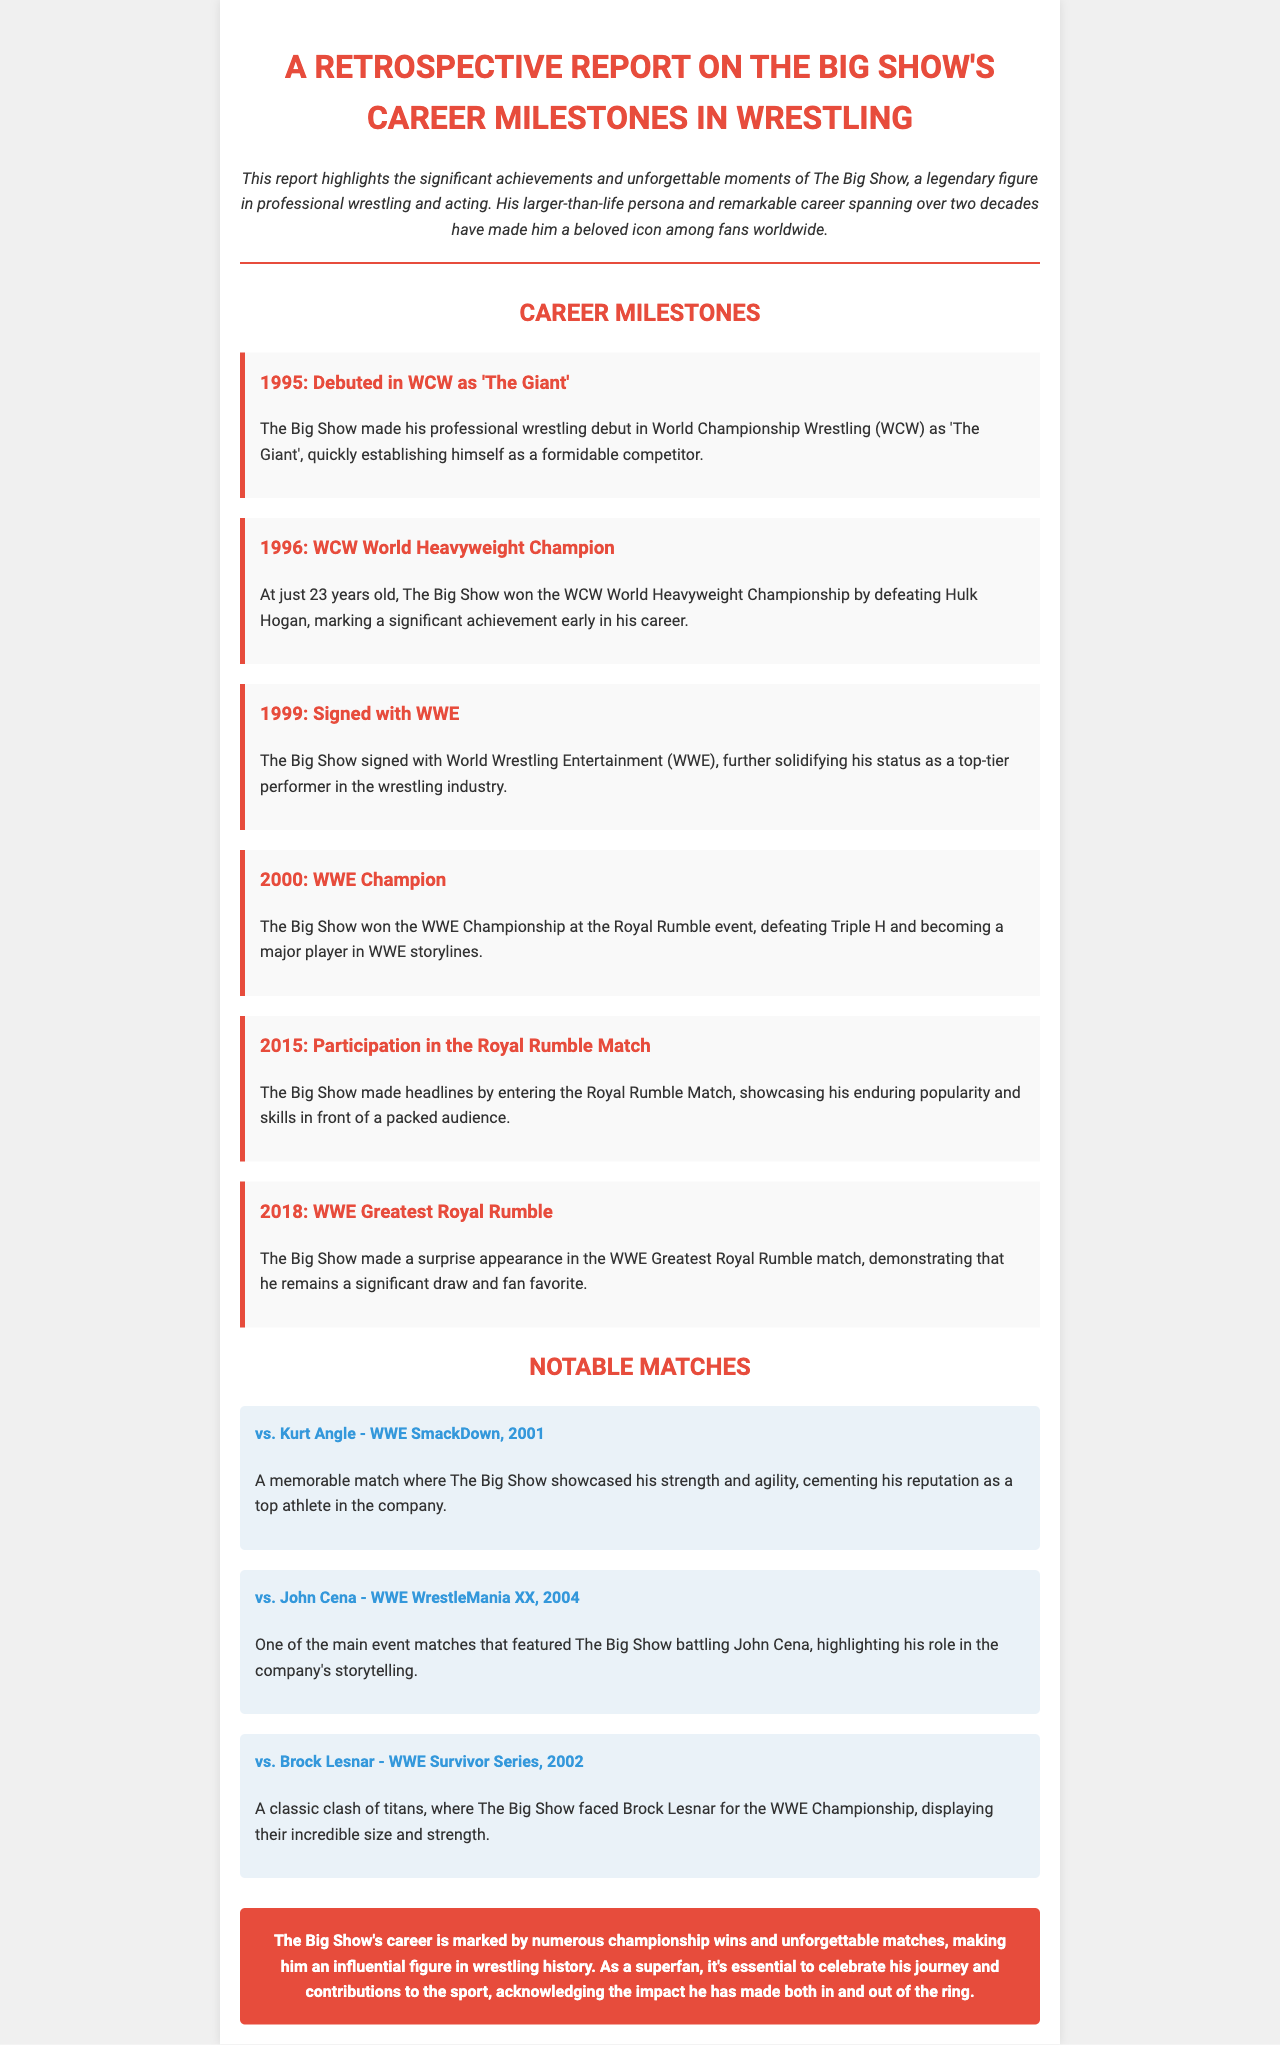What year did The Big Show debut in WCW? The Big Show made his debut in WCW in 1995.
Answer: 1995 Who did The Big Show defeat to win the WCW World Heavyweight Championship? The Big Show won the WCW World Heavyweight Championship by defeating Hulk Hogan.
Answer: Hulk Hogan What championship did The Big Show win at the Royal Rumble in 2000? The Big Show won the WWE Championship at the Royal Rumble in 2000.
Answer: WWE Championship Which match did The Big Show participate in during WWE WrestleMania XX? The Big Show battled John Cena in WWE WrestleMania XX.
Answer: John Cena What significant event did The Big Show participate in 2018? The Big Show made a surprise appearance in the WWE Greatest Royal Rumble match in 2018.
Answer: WWE Greatest Royal Rumble How old was The Big Show when he won the WCW World Heavyweight Championship? The Big Show was 23 years old when he won the WCW World Heavyweight Championship.
Answer: 23 years old What is notable about The Big Show's match against Brock Lesnar? The match was a classic clash of titans for the WWE Championship.
Answer: Classic clash of titans Which tagline is used for the introduction in the report? The introduction is an italic description emphasizing The Big Show as a legendary figure in wrestling and acting.
Answer: Legendary figure What type of matches does the report highlight? The report highlights championship wins and noteworthy matches throughout The Big Show's career.
Answer: Championship wins and noteworthy matches 